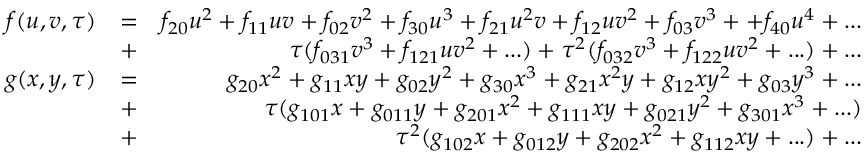<formula> <loc_0><loc_0><loc_500><loc_500>\begin{array} { r l r } { f ( u , v , \tau ) } & { = } & { f _ { 2 0 } u ^ { 2 } + f _ { 1 1 } u v + f _ { 0 2 } v ^ { 2 } + f _ { 3 0 } u ^ { 3 } + f _ { 2 1 } u ^ { 2 } v + f _ { 1 2 } u v ^ { 2 } + f _ { 0 3 } v ^ { 3 } + + f _ { 4 0 } u ^ { 4 } + \dots } \\ & { + } & { \tau ( f _ { 0 3 1 } v ^ { 3 } + f _ { 1 2 1 } u v ^ { 2 } + \dots ) + \tau ^ { 2 } ( f _ { 0 3 2 } v ^ { 3 } + f _ { 1 2 2 } u v ^ { 2 } + \dots ) + \dots } \\ { g ( x , y , \tau ) } & { = } & { g _ { 2 0 } x ^ { 2 } + g _ { 1 1 } x y + g _ { 0 2 } y ^ { 2 } + g _ { 3 0 } x ^ { 3 } + g _ { 2 1 } x ^ { 2 } y + g _ { 1 2 } x y ^ { 2 } + g _ { 0 3 } y ^ { 3 } + \dots } \\ & { + } & { \tau ( g _ { 1 0 1 } x + g _ { 0 1 1 } y + g _ { 2 0 1 } x ^ { 2 } + g _ { 1 1 1 } x y + g _ { 0 2 1 } y ^ { 2 } + g _ { 3 0 1 } x ^ { 3 } + \dots ) } \\ & { + } & { \tau ^ { 2 } ( g _ { 1 0 2 } x + g _ { 0 1 2 } y + g _ { 2 0 2 } x ^ { 2 } + g _ { 1 1 2 } x y + \dots ) + \dots } \end{array}</formula> 